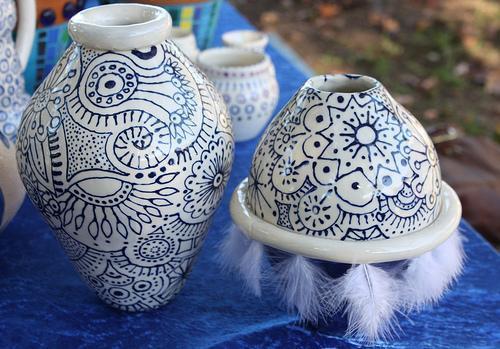How many vases on the table?
Give a very brief answer. 2. How many feathers on the small vase?
Give a very brief answer. 6. 